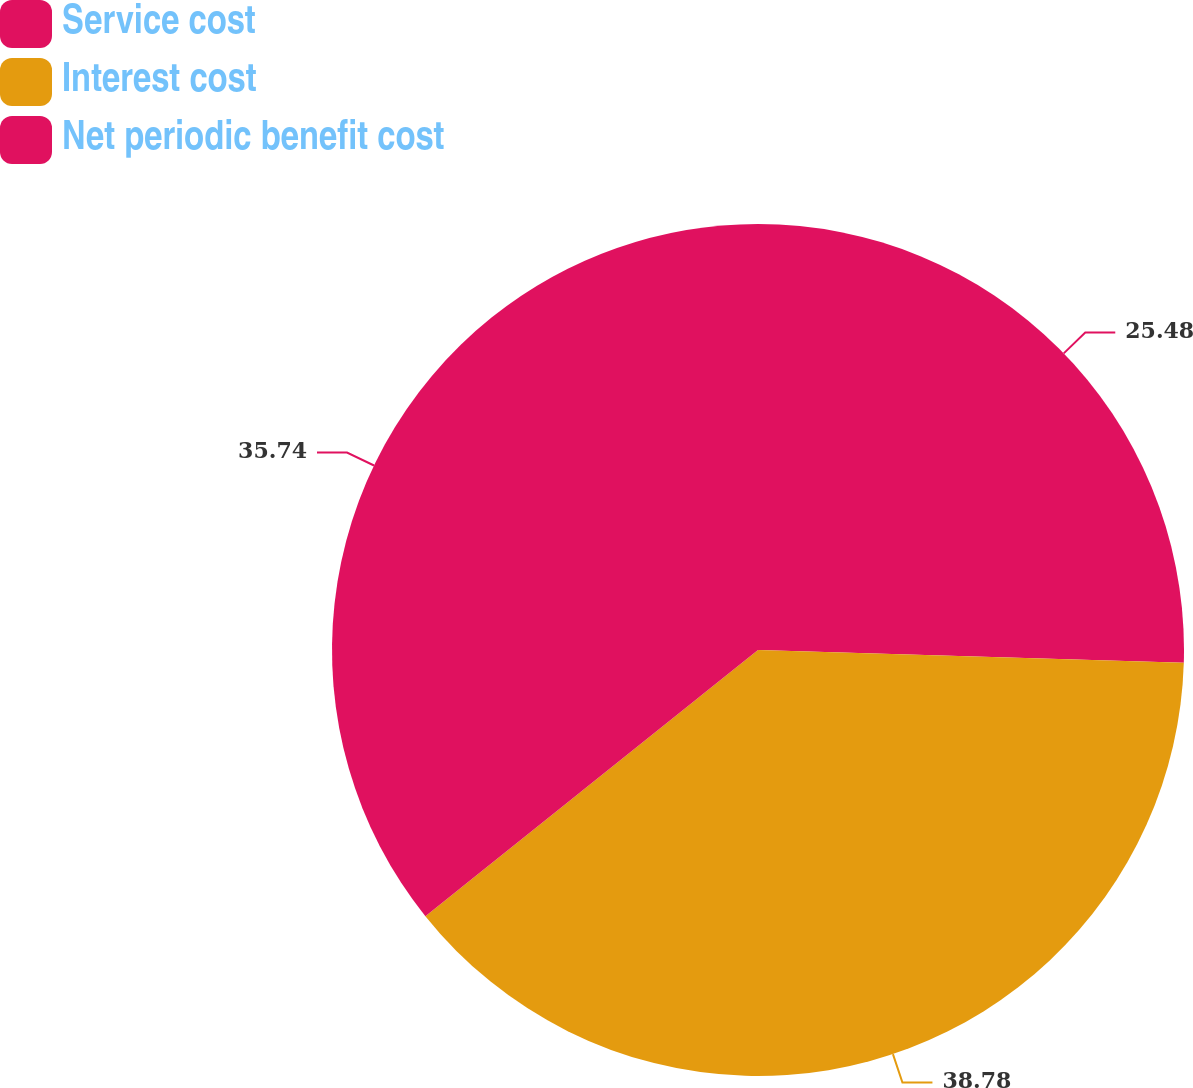Convert chart to OTSL. <chart><loc_0><loc_0><loc_500><loc_500><pie_chart><fcel>Service cost<fcel>Interest cost<fcel>Net periodic benefit cost<nl><fcel>25.48%<fcel>38.78%<fcel>35.74%<nl></chart> 